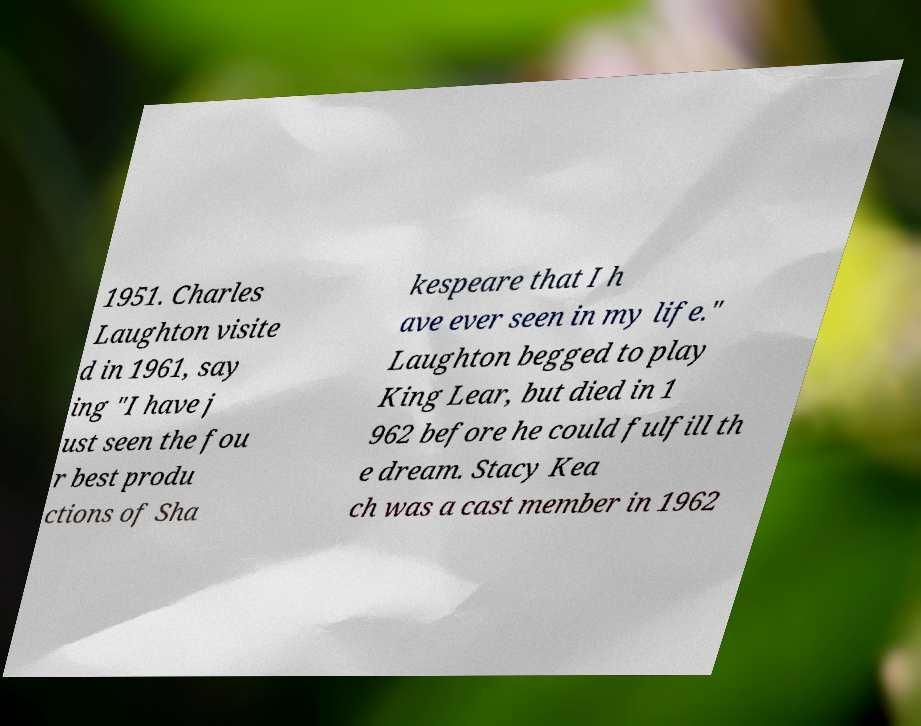Can you accurately transcribe the text from the provided image for me? 1951. Charles Laughton visite d in 1961, say ing "I have j ust seen the fou r best produ ctions of Sha kespeare that I h ave ever seen in my life." Laughton begged to play King Lear, but died in 1 962 before he could fulfill th e dream. Stacy Kea ch was a cast member in 1962 